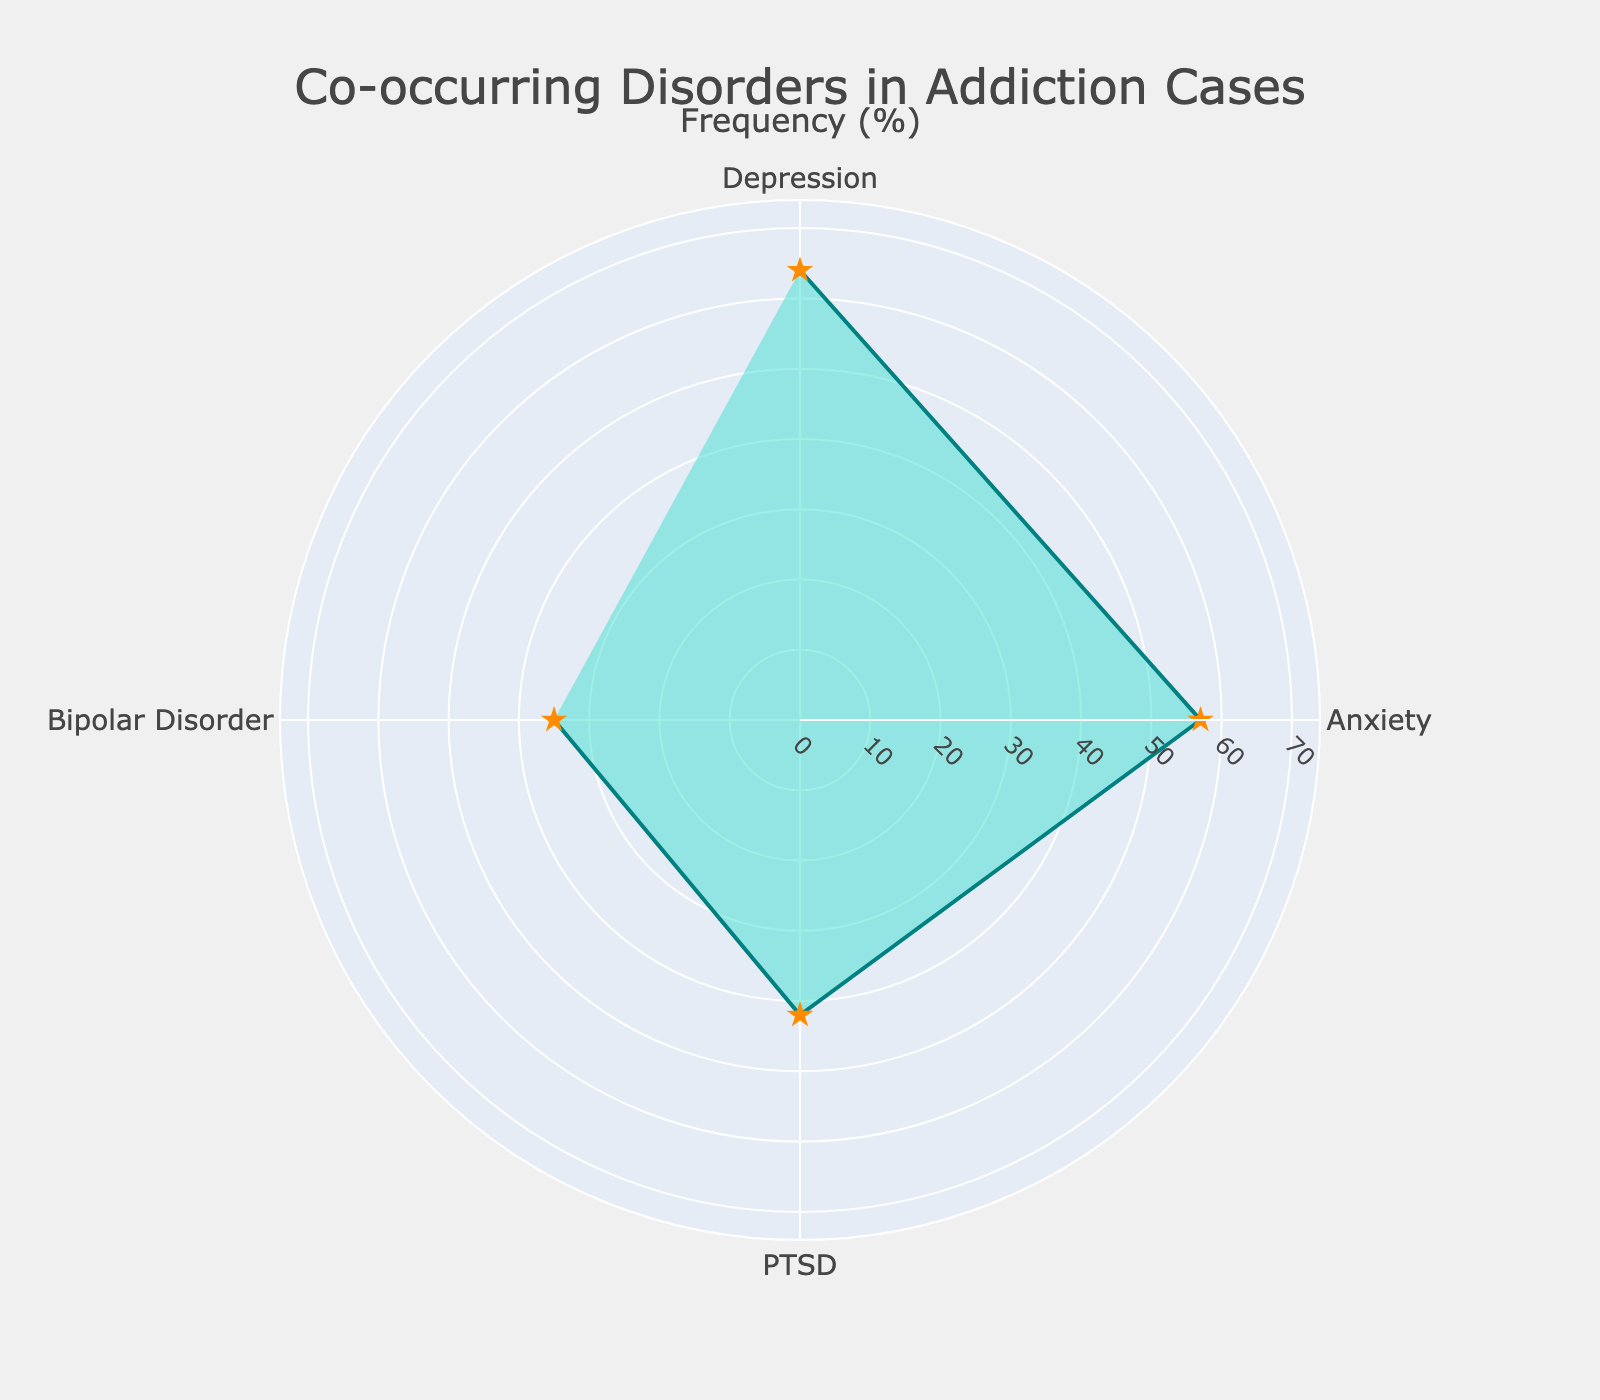What is the title of the figure? The title is usually prominently displayed at the top of the figure and provides an overview of the data being presented.
Answer: Co-occurring Disorders in Addiction Cases How many conditions are visualized in the radar chart? You can count the number of distinct categories (conditions) around the radar chart.
Answer: Four Which condition has the highest frequency in addiction cases? Look for the outermost point among the conditions to determine which has the highest frequency.
Answer: Depression Which condition has the lowest frequency in addiction cases? Look for the innermost point among the conditions to determine which has the lowest frequency.
Answer: Bipolar Disorder What is the frequency of PTSD in addiction cases? Find the label for PTSD and read the corresponding value in the radar chart.
Answer: 42% How much higher is the frequency of Depression compared to Bipolar Disorder? Subtract the frequency of Bipolar Disorder from the frequency of Depression.
Answer: 64% - 35% = 29% What is the sum of the frequencies of Anxiety and Depression in addiction cases? Add the frequencies of Anxiety and Depression together.
Answer: 57% + 64% = 121% Are there any conditions with nearly the same frequency? Compare the values of the four conditions to see if any are very close to one another.
Answer: No, all frequencies are distinct What is the range of frequencies among the conditions? Subtract the lowest frequency value from the highest frequency value among the conditions.
Answer: 64% - 35% = 29% 